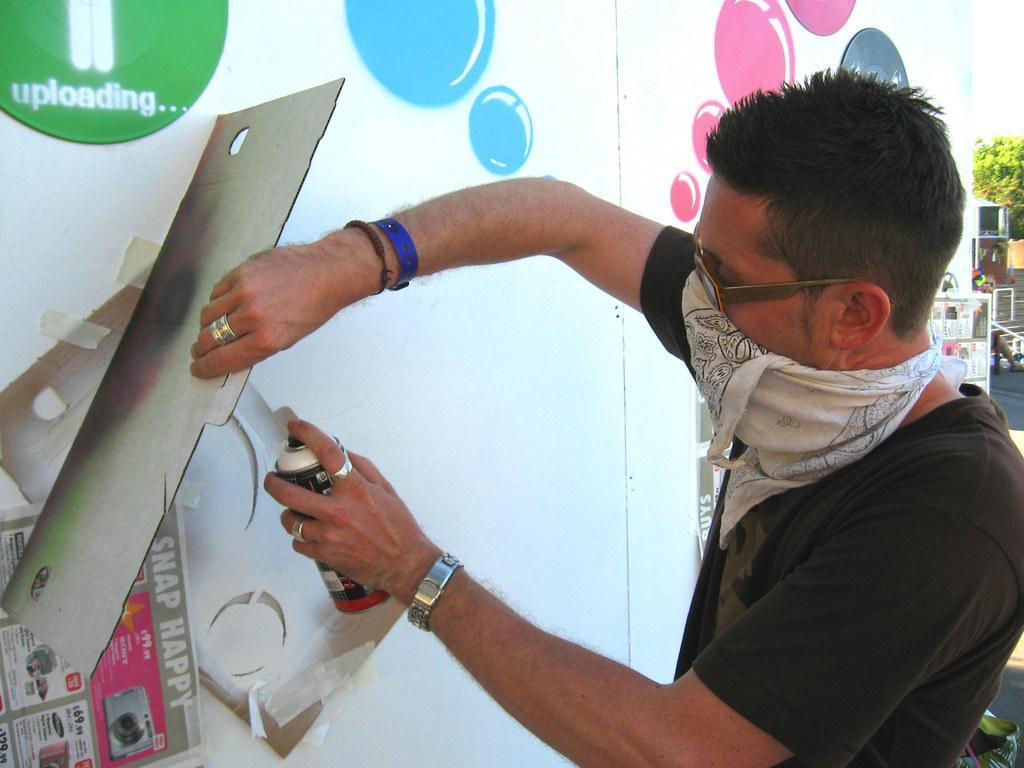How would you summarize this image in a sentence or two? In this picture we can see a man, goggles, cloth, bottle, board, poster, painting on the surface and in the background we can see a tree, steps, person and some objects. 